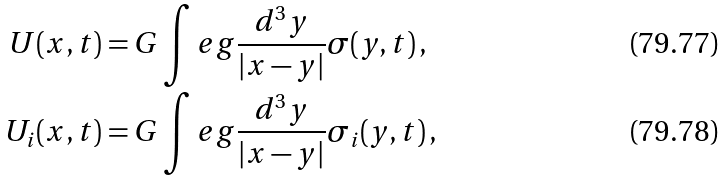<formula> <loc_0><loc_0><loc_500><loc_500>U ( { x , t } ) & = G \int e g \frac { d ^ { 3 } y } { | x - y | } \sigma ( { { y } , t } ) \, , \\ U _ { i } ( { x , t } ) & = G \int e g \frac { d ^ { 3 } y } { | x - y | } \sigma _ { i } ( { y , t } ) \, ,</formula> 